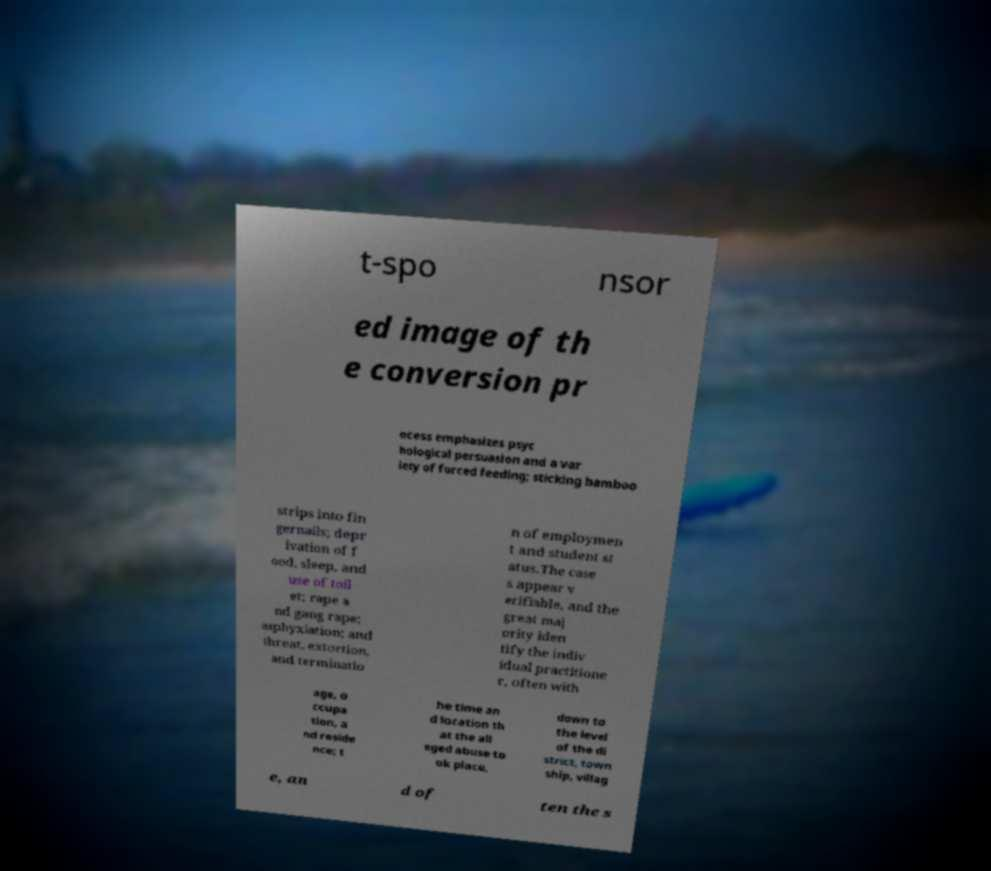For documentation purposes, I need the text within this image transcribed. Could you provide that? t-spo nsor ed image of th e conversion pr ocess emphasizes psyc hological persuasion and a var iety of forced feeding; sticking bamboo strips into fin gernails; depr ivation of f ood, sleep, and use of toil et; rape a nd gang rape; asphyxiation; and threat, extortion, and terminatio n of employmen t and student st atus.The case s appear v erifiable, and the great maj ority iden tify the indiv idual practitione r, often with age, o ccupa tion, a nd reside nce; t he time an d location th at the all eged abuse to ok place, down to the level of the di strict, town ship, villag e, an d of ten the s 